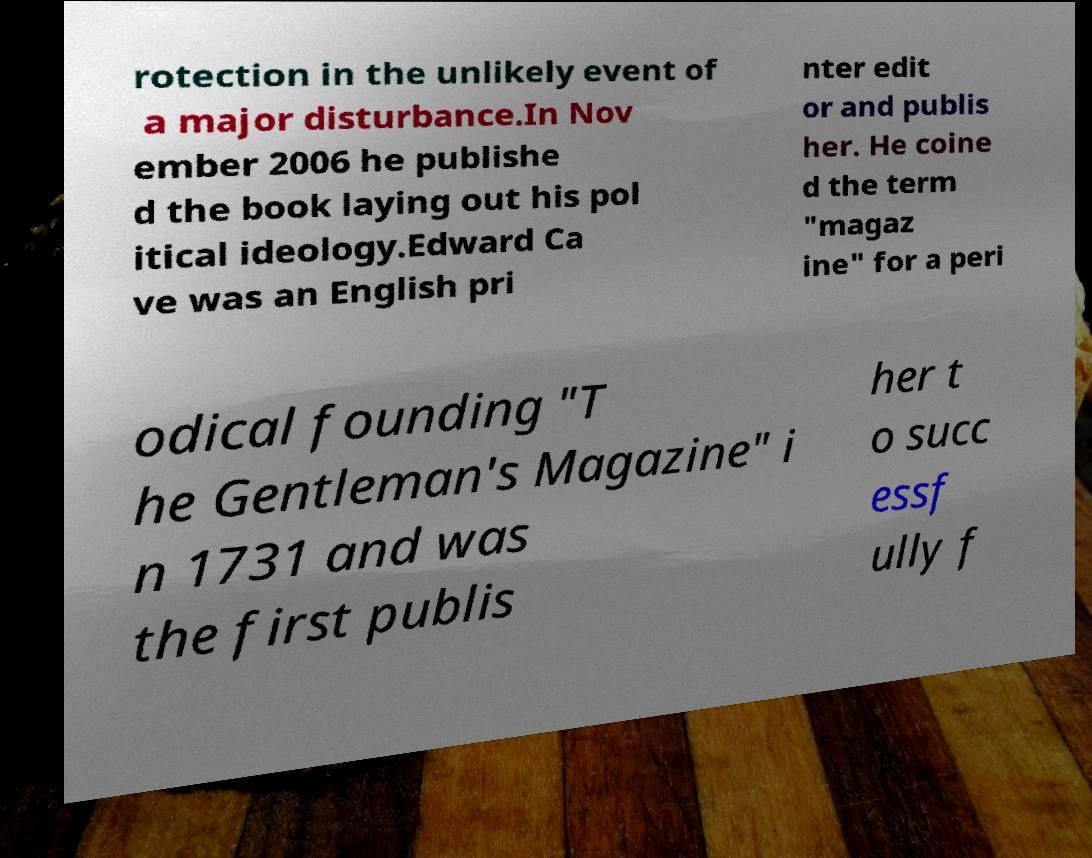Can you accurately transcribe the text from the provided image for me? rotection in the unlikely event of a major disturbance.In Nov ember 2006 he publishe d the book laying out his pol itical ideology.Edward Ca ve was an English pri nter edit or and publis her. He coine d the term "magaz ine" for a peri odical founding "T he Gentleman's Magazine" i n 1731 and was the first publis her t o succ essf ully f 